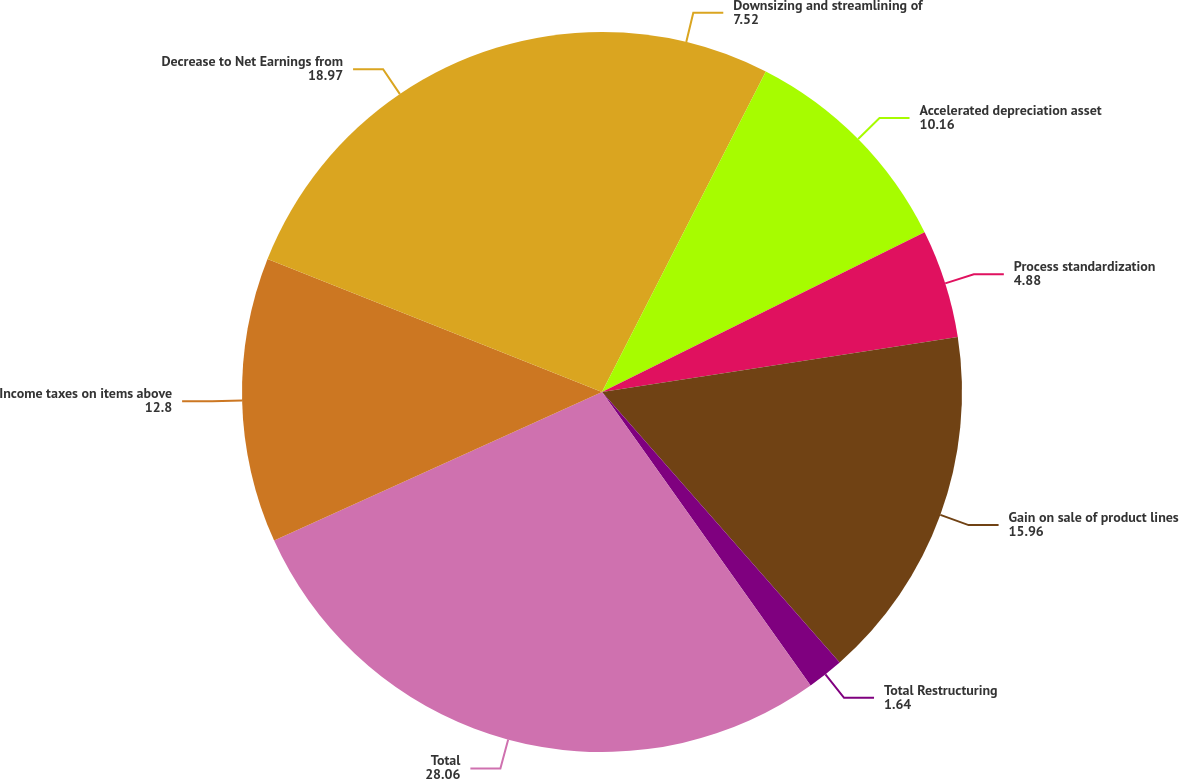Convert chart. <chart><loc_0><loc_0><loc_500><loc_500><pie_chart><fcel>Downsizing and streamlining of<fcel>Accelerated depreciation asset<fcel>Process standardization<fcel>Gain on sale of product lines<fcel>Total Restructuring<fcel>Total<fcel>Income taxes on items above<fcel>Decrease to Net Earnings from<nl><fcel>7.52%<fcel>10.16%<fcel>4.88%<fcel>15.96%<fcel>1.64%<fcel>28.06%<fcel>12.8%<fcel>18.97%<nl></chart> 